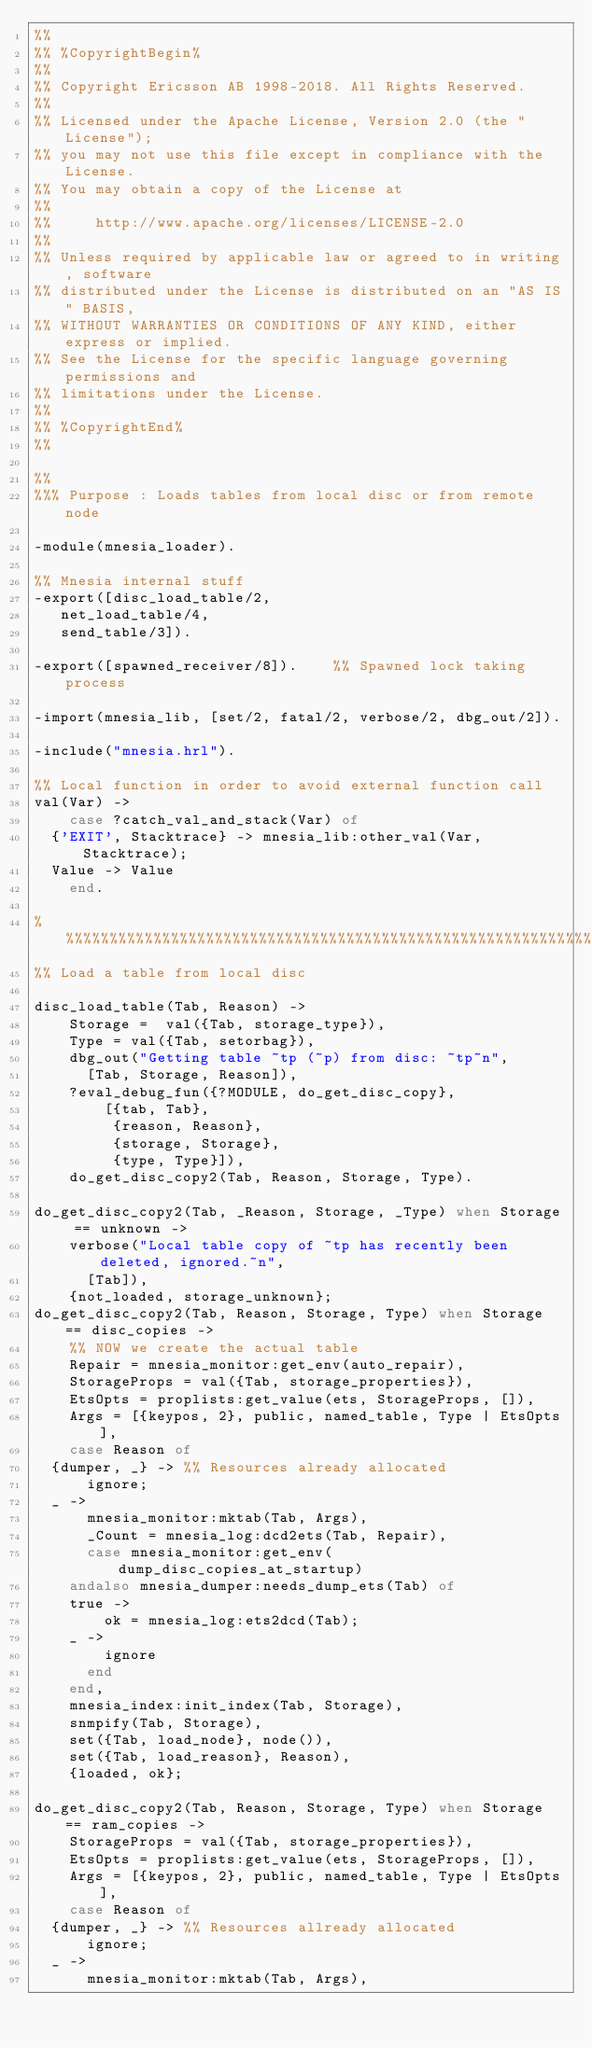<code> <loc_0><loc_0><loc_500><loc_500><_Erlang_>%%
%% %CopyrightBegin%
%%
%% Copyright Ericsson AB 1998-2018. All Rights Reserved.
%%
%% Licensed under the Apache License, Version 2.0 (the "License");
%% you may not use this file except in compliance with the License.
%% You may obtain a copy of the License at
%%
%%     http://www.apache.org/licenses/LICENSE-2.0
%%
%% Unless required by applicable law or agreed to in writing, software
%% distributed under the License is distributed on an "AS IS" BASIS,
%% WITHOUT WARRANTIES OR CONDITIONS OF ANY KIND, either express or implied.
%% See the License for the specific language governing permissions and
%% limitations under the License.
%%
%% %CopyrightEnd%
%%

%%
%%% Purpose : Loads tables from local disc or from remote node

-module(mnesia_loader).

%% Mnesia internal stuff
-export([disc_load_table/2,
	 net_load_table/4,
	 send_table/3]).

-export([spawned_receiver/8]).    %% Spawned lock taking process

-import(mnesia_lib, [set/2, fatal/2, verbose/2, dbg_out/2]).

-include("mnesia.hrl").

%% Local function in order to avoid external function call
val(Var) ->
    case ?catch_val_and_stack(Var) of
	{'EXIT', Stacktrace} -> mnesia_lib:other_val(Var, Stacktrace);
	Value -> Value
    end.

%%%%%%%%%%%%%%%%%%%%%%%%%%%%%%%%%%%%%%%%%%%%%%%%%%%%%%%%%%%%%%%%%%%%%%%%%%%
%% Load a table from local disc

disc_load_table(Tab, Reason) ->
    Storage =  val({Tab, storage_type}),
    Type = val({Tab, setorbag}),
    dbg_out("Getting table ~tp (~p) from disc: ~tp~n",
	    [Tab, Storage, Reason]),
    ?eval_debug_fun({?MODULE, do_get_disc_copy},
		    [{tab, Tab},
		     {reason, Reason},
		     {storage, Storage},
		     {type, Type}]),
    do_get_disc_copy2(Tab, Reason, Storage, Type).

do_get_disc_copy2(Tab, _Reason, Storage, _Type) when Storage == unknown ->
    verbose("Local table copy of ~tp has recently been deleted, ignored.~n",
	    [Tab]),
    {not_loaded, storage_unknown};
do_get_disc_copy2(Tab, Reason, Storage, Type) when Storage == disc_copies ->
    %% NOW we create the actual table
    Repair = mnesia_monitor:get_env(auto_repair),
    StorageProps = val({Tab, storage_properties}),
    EtsOpts = proplists:get_value(ets, StorageProps, []),
    Args = [{keypos, 2}, public, named_table, Type | EtsOpts],
    case Reason of
	{dumper, _} -> %% Resources already allocated
	    ignore;
	_ ->
	    mnesia_monitor:mktab(Tab, Args),
	    _Count = mnesia_log:dcd2ets(Tab, Repair),
	    case mnesia_monitor:get_env(dump_disc_copies_at_startup)
		andalso mnesia_dumper:needs_dump_ets(Tab) of
		true ->
		    ok = mnesia_log:ets2dcd(Tab);
		_ ->
		    ignore
	    end
    end,
    mnesia_index:init_index(Tab, Storage),
    snmpify(Tab, Storage),
    set({Tab, load_node}, node()),
    set({Tab, load_reason}, Reason),
    {loaded, ok};

do_get_disc_copy2(Tab, Reason, Storage, Type) when Storage == ram_copies ->
    StorageProps = val({Tab, storage_properties}),
    EtsOpts = proplists:get_value(ets, StorageProps, []),
    Args = [{keypos, 2}, public, named_table, Type | EtsOpts],
    case Reason of
	{dumper, _} -> %% Resources allready allocated
	    ignore;
	_ ->
	    mnesia_monitor:mktab(Tab, Args),</code> 